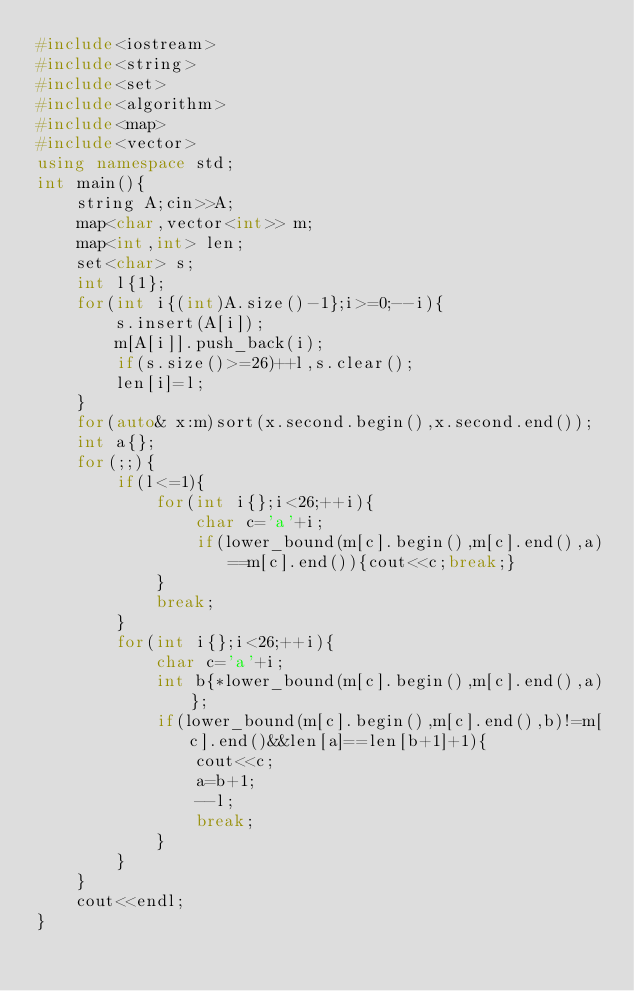Convert code to text. <code><loc_0><loc_0><loc_500><loc_500><_C++_>#include<iostream>
#include<string>
#include<set>
#include<algorithm>
#include<map>
#include<vector>
using namespace std;
int main(){
    string A;cin>>A;
    map<char,vector<int>> m;
    map<int,int> len;
    set<char> s;
    int l{1};
    for(int i{(int)A.size()-1};i>=0;--i){
        s.insert(A[i]);
        m[A[i]].push_back(i);
        if(s.size()>=26)++l,s.clear();
        len[i]=l;
    }
    for(auto& x:m)sort(x.second.begin(),x.second.end());
    int a{};
    for(;;){
        if(l<=1){
            for(int i{};i<26;++i){
                char c='a'+i;
                if(lower_bound(m[c].begin(),m[c].end(),a)==m[c].end()){cout<<c;break;}
            }
            break;
        }
        for(int i{};i<26;++i){
            char c='a'+i;
            int b{*lower_bound(m[c].begin(),m[c].end(),a)};
            if(lower_bound(m[c].begin(),m[c].end(),b)!=m[c].end()&&len[a]==len[b+1]+1){
                cout<<c;
                a=b+1;
                --l;
                break;
            }
        }
    }
    cout<<endl;
}
</code> 